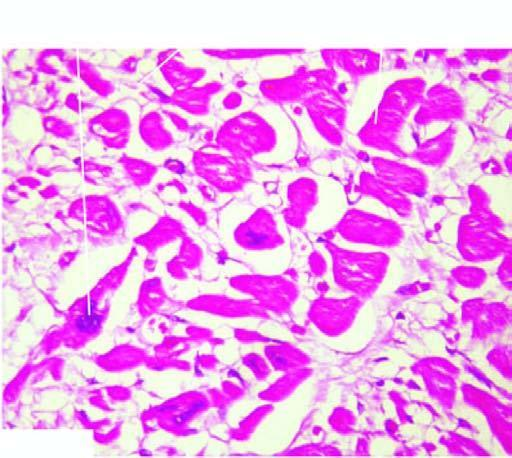re the myocardial muscle fibres thick with abundance of eosinophilic cytoplasm?
Answer the question using a single word or phrase. Yes 